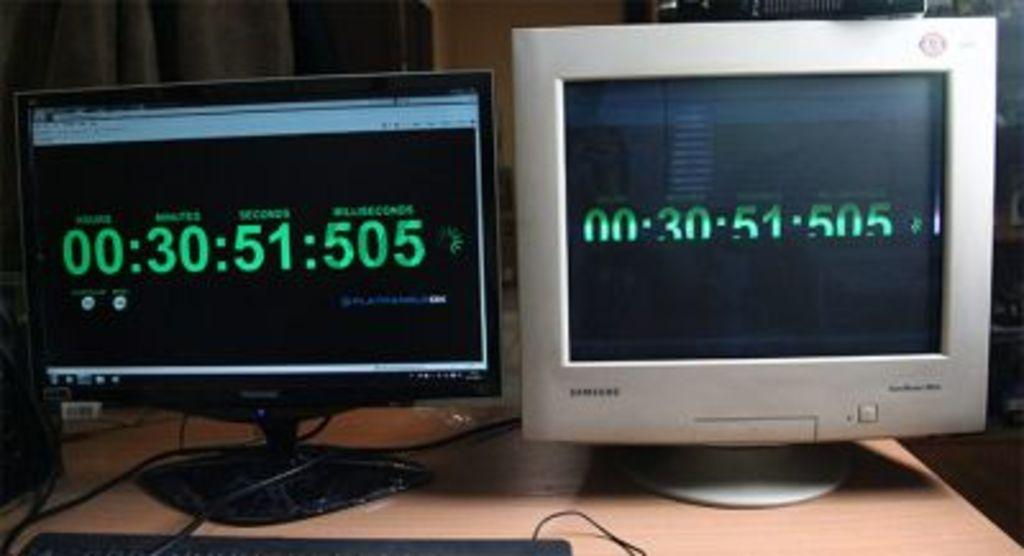<image>
Describe the image concisely. the number 30 is on a black screen on a monitor 